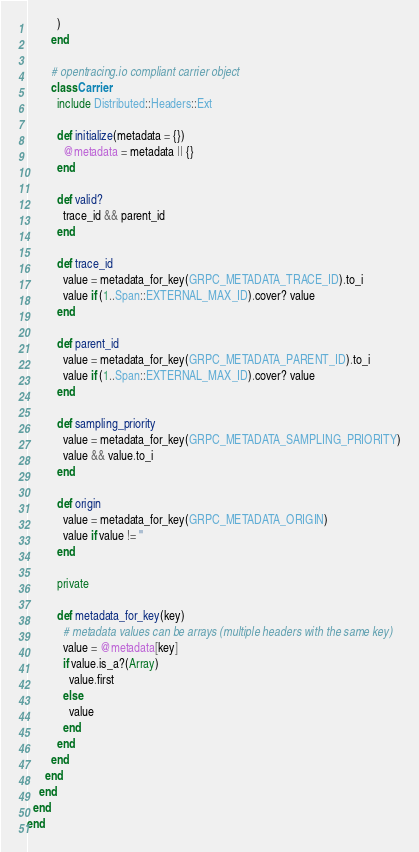<code> <loc_0><loc_0><loc_500><loc_500><_Ruby_>          )
        end

        # opentracing.io compliant carrier object
        class Carrier
          include Distributed::Headers::Ext

          def initialize(metadata = {})
            @metadata = metadata || {}
          end

          def valid?
            trace_id && parent_id
          end

          def trace_id
            value = metadata_for_key(GRPC_METADATA_TRACE_ID).to_i
            value if (1..Span::EXTERNAL_MAX_ID).cover? value
          end

          def parent_id
            value = metadata_for_key(GRPC_METADATA_PARENT_ID).to_i
            value if (1..Span::EXTERNAL_MAX_ID).cover? value
          end

          def sampling_priority
            value = metadata_for_key(GRPC_METADATA_SAMPLING_PRIORITY)
            value && value.to_i
          end

          def origin
            value = metadata_for_key(GRPC_METADATA_ORIGIN)
            value if value != ''
          end

          private

          def metadata_for_key(key)
            # metadata values can be arrays (multiple headers with the same key)
            value = @metadata[key]
            if value.is_a?(Array)
              value.first
            else
              value
            end
          end
        end
      end
    end
  end
end
</code> 